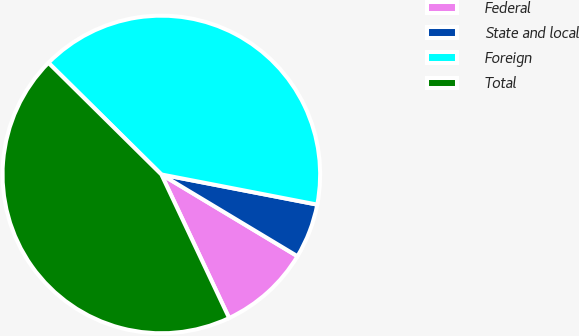<chart> <loc_0><loc_0><loc_500><loc_500><pie_chart><fcel>Federal<fcel>State and local<fcel>Foreign<fcel>Total<nl><fcel>9.37%<fcel>5.57%<fcel>40.63%<fcel>44.43%<nl></chart> 